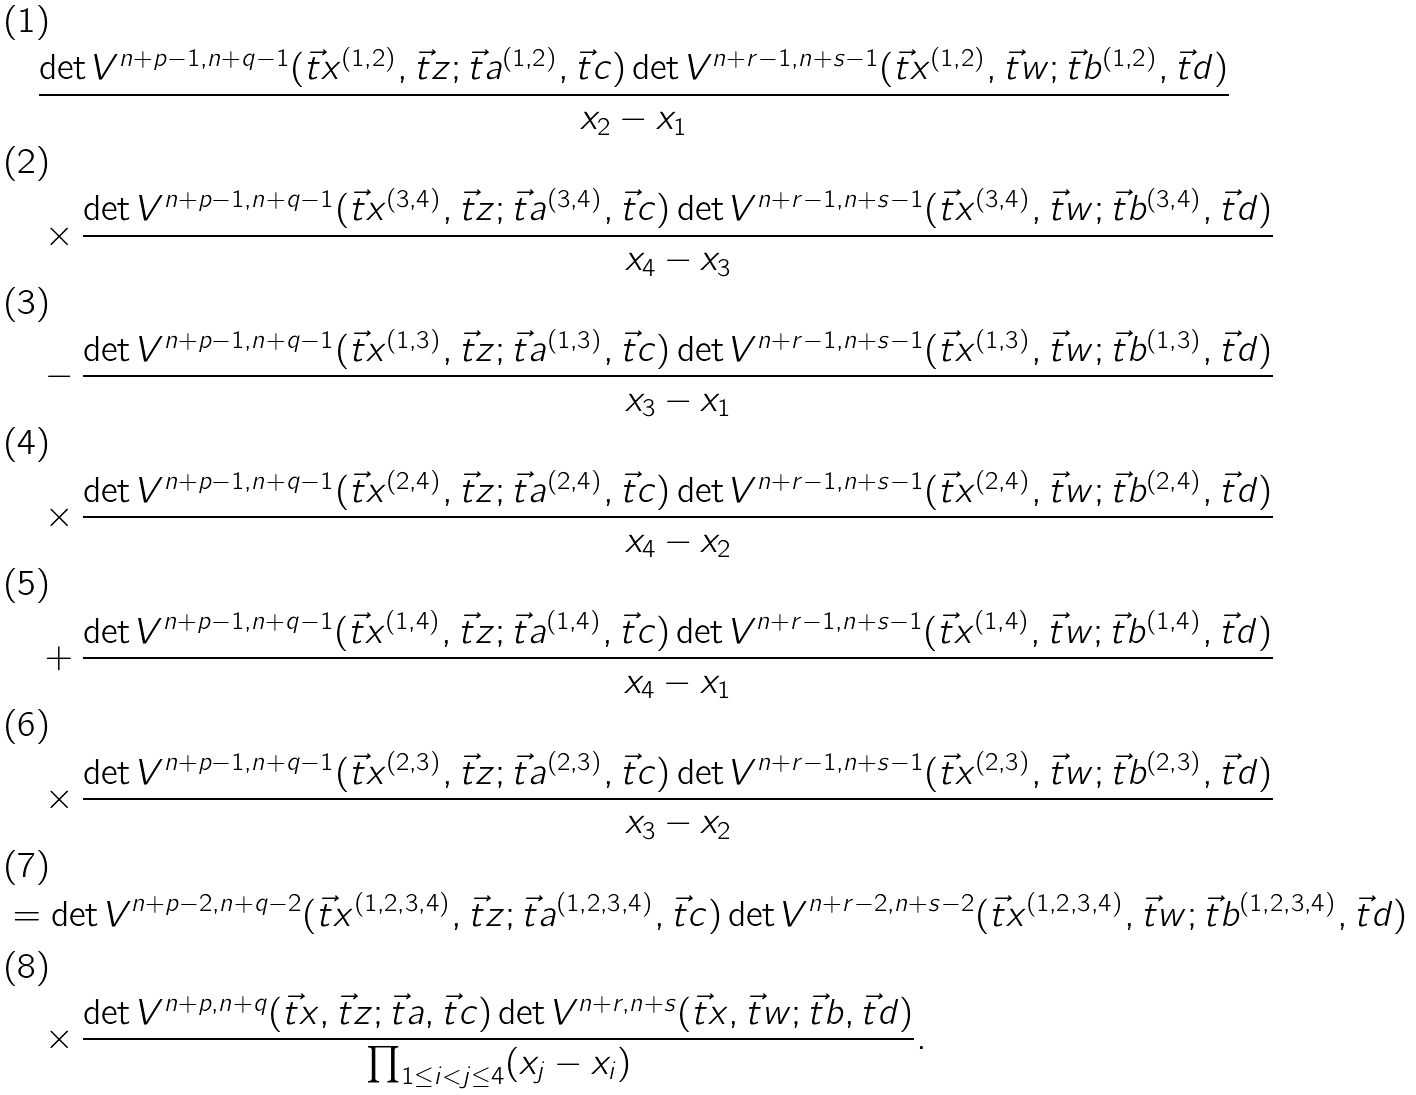Convert formula to latex. <formula><loc_0><loc_0><loc_500><loc_500>& \quad \frac { \det V ^ { n + p - 1 , n + q - 1 } ( \vec { t } x ^ { ( 1 , 2 ) } , \vec { t } z ; \vec { t } a ^ { ( 1 , 2 ) } , \vec { t } c ) \det V ^ { n + r - 1 , n + s - 1 } ( \vec { t } x ^ { ( 1 , 2 ) } , \vec { t } w ; \vec { t } b ^ { ( 1 , 2 ) } , \vec { t } d ) } { x _ { 2 } - x _ { 1 } } \\ & \quad \times \frac { \det V ^ { n + p - 1 , n + q - 1 } ( \vec { t } x ^ { ( 3 , 4 ) } , \vec { t } z ; \vec { t } a ^ { ( 3 , 4 ) } , \vec { t } c ) \det V ^ { n + r - 1 , n + s - 1 } ( \vec { t } x ^ { ( 3 , 4 ) } , \vec { t } w ; \vec { t } b ^ { ( 3 , 4 ) } , \vec { t } d ) } { x _ { 4 } - x _ { 3 } } \\ & \quad - \frac { \det V ^ { n + p - 1 , n + q - 1 } ( \vec { t } x ^ { ( 1 , 3 ) } , \vec { t } z ; \vec { t } a ^ { ( 1 , 3 ) } , \vec { t } c ) \det V ^ { n + r - 1 , n + s - 1 } ( \vec { t } x ^ { ( 1 , 3 ) } , \vec { t } w ; \vec { t } b ^ { ( 1 , 3 ) } , \vec { t } d ) } { x _ { 3 } - x _ { 1 } } \\ & \quad \times \frac { \det V ^ { n + p - 1 , n + q - 1 } ( \vec { t } x ^ { ( 2 , 4 ) } , \vec { t } z ; \vec { t } a ^ { ( 2 , 4 ) } , \vec { t } c ) \det V ^ { n + r - 1 , n + s - 1 } ( \vec { t } x ^ { ( 2 , 4 ) } , \vec { t } w ; \vec { t } b ^ { ( 2 , 4 ) } , \vec { t } d ) } { x _ { 4 } - x _ { 2 } } \\ & \quad + \frac { \det V ^ { n + p - 1 , n + q - 1 } ( \vec { t } x ^ { ( 1 , 4 ) } , \vec { t } z ; \vec { t } a ^ { ( 1 , 4 ) } , \vec { t } c ) \det V ^ { n + r - 1 , n + s - 1 } ( \vec { t } x ^ { ( 1 , 4 ) } , \vec { t } w ; \vec { t } b ^ { ( 1 , 4 ) } , \vec { t } d ) } { x _ { 4 } - x _ { 1 } } \\ & \quad \times \frac { \det V ^ { n + p - 1 , n + q - 1 } ( \vec { t } x ^ { ( 2 , 3 ) } , \vec { t } z ; \vec { t } a ^ { ( 2 , 3 ) } , \vec { t } c ) \det V ^ { n + r - 1 , n + s - 1 } ( \vec { t } x ^ { ( 2 , 3 ) } , \vec { t } w ; \vec { t } b ^ { ( 2 , 3 ) } , \vec { t } d ) } { x _ { 3 } - x _ { 2 } } \\ & = \det V ^ { n + p - 2 , n + q - 2 } ( \vec { t } x ^ { ( 1 , 2 , 3 , 4 ) } , \vec { t } z ; \vec { t } a ^ { ( 1 , 2 , 3 , 4 ) } , \vec { t } c ) \det V ^ { n + r - 2 , n + s - 2 } ( \vec { t } x ^ { ( 1 , 2 , 3 , 4 ) } , \vec { t } w ; \vec { t } b ^ { ( 1 , 2 , 3 , 4 ) } , \vec { t } d ) \\ & \quad \times \frac { \det V ^ { n + p , n + q } ( \vec { t } x , \vec { t } z ; \vec { t } a , \vec { t } c ) \det V ^ { n + r , n + s } ( \vec { t } x , \vec { t } w ; \vec { t } b , \vec { t } d ) } { \prod _ { 1 \leq i < j \leq 4 } ( x _ { j } - x _ { i } ) } .</formula> 